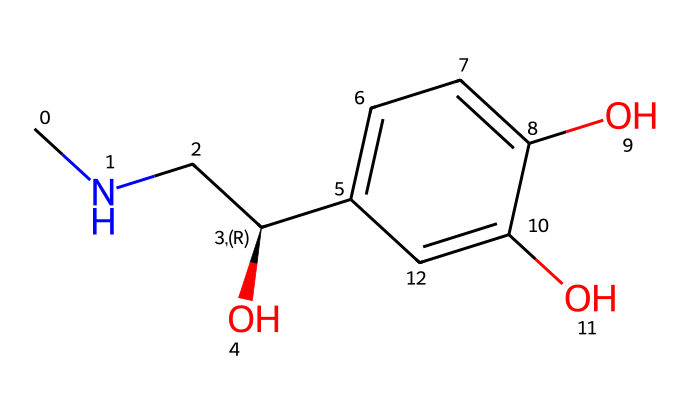What is the molecular formula of this chemical? To determine the molecular formula, we need to count each type of atom in the chemical structure represented by the SMILES string. The SMILES indicates there are 9 carbon (C) atoms, 13 hydrogen (H) atoms, 1 nitrogen (N) atom, and 3 oxygen (O) atoms. Therefore, the molecular formula is C9H13N3O3.
Answer: C9H13N3O3 How many hydroxyl (–OH) groups are present in this structure? By examining the chemical structure's SMILES representation, we can identify the –OH groups (hydroxyl groups). In the structure, there are 3 instances where –OH is present attached to the aromatic ring, indicating there are three hydroxyl groups.
Answer: 3 What type of biological function does this chemical primarily serve? Adrenaline primarily acts as a hormone released during stress or physical activity, increasing heart rate and energy availability, which relates to the fight-or-flight response.
Answer: hormone Does this chemical contain a chiral center? A chiral center is a carbon atom that has four different groups attached to it. In this structure, the carbon atom in the chain stands out because it is connected to an amine group, hydroxyl group, hydrogen, and the rest of the carbon skeleton. Hence, it is chiral.
Answer: yes What is the primary effect of adrenaline in the human body? Adrenaline primarily increases heart rate and blood flow to muscles during stress or intense physical activity, supporting the body's response.
Answer: increases heart rate 